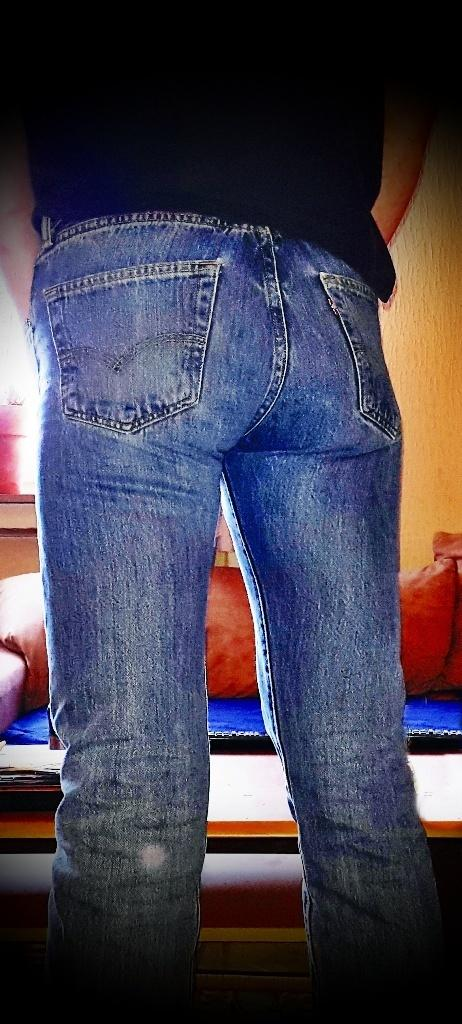What is present in the image? There is a person in the image. Can you describe the person's body in the image? The person's body is visible in the image. What can be seen in the background of the image? There is a table, a couch, and a wall in the background of the image. What type of cork is being used to hold the person's receipt in the image? There is no cork or receipt present in the image. 